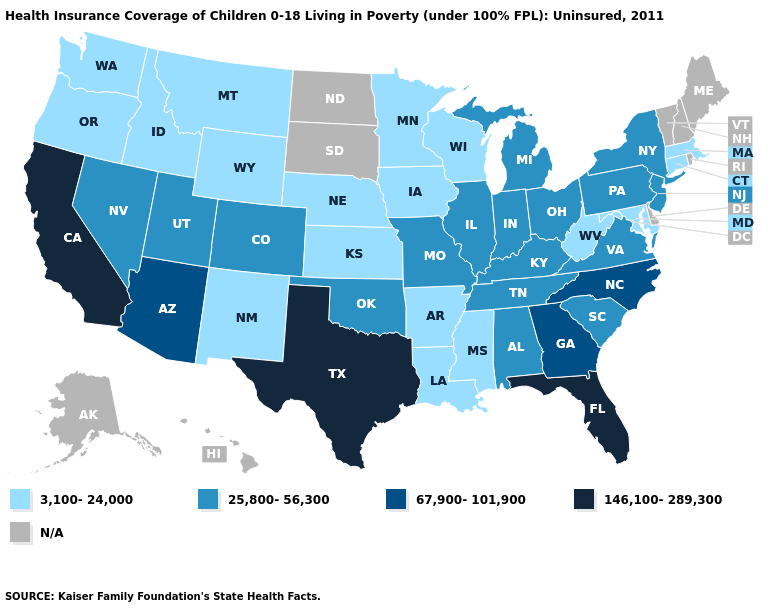What is the highest value in states that border Tennessee?
Keep it brief. 67,900-101,900. What is the highest value in the Northeast ?
Keep it brief. 25,800-56,300. What is the value of Indiana?
Give a very brief answer. 25,800-56,300. Among the states that border New Mexico , which have the lowest value?
Keep it brief. Colorado, Oklahoma, Utah. Which states have the lowest value in the West?
Quick response, please. Idaho, Montana, New Mexico, Oregon, Washington, Wyoming. Which states have the lowest value in the USA?
Concise answer only. Arkansas, Connecticut, Idaho, Iowa, Kansas, Louisiana, Maryland, Massachusetts, Minnesota, Mississippi, Montana, Nebraska, New Mexico, Oregon, Washington, West Virginia, Wisconsin, Wyoming. What is the value of Michigan?
Give a very brief answer. 25,800-56,300. What is the highest value in the South ?
Write a very short answer. 146,100-289,300. What is the value of South Dakota?
Give a very brief answer. N/A. Does Iowa have the highest value in the USA?
Give a very brief answer. No. Which states have the highest value in the USA?
Keep it brief. California, Florida, Texas. What is the lowest value in the MidWest?
Answer briefly. 3,100-24,000. Does the map have missing data?
Short answer required. Yes. 